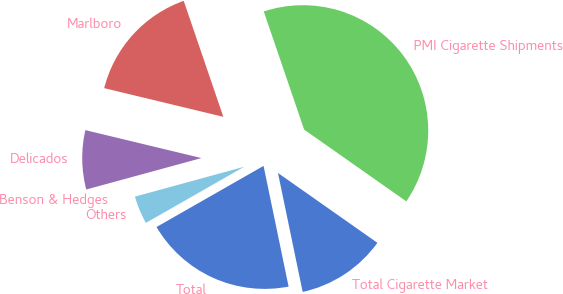<chart> <loc_0><loc_0><loc_500><loc_500><pie_chart><fcel>Total Cigarette Market<fcel>PMI Cigarette Shipments<fcel>Marlboro<fcel>Delicados<fcel>Benson & Hedges<fcel>Others<fcel>Total<nl><fcel>12.0%<fcel>39.99%<fcel>16.0%<fcel>8.0%<fcel>0.01%<fcel>4.01%<fcel>20.0%<nl></chart> 